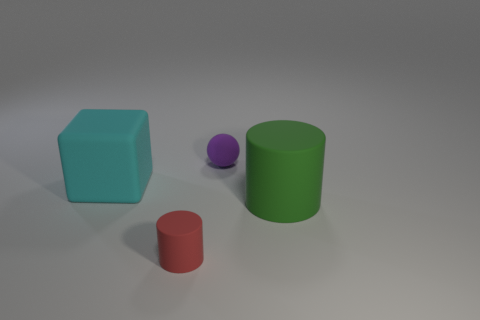Do the big green object and the small purple ball have the same material?
Make the answer very short. Yes. There is another object that is the same shape as the tiny red matte thing; what color is it?
Offer a terse response. Green. What number of large cubes are the same material as the purple ball?
Make the answer very short. 1. There is a red matte object; what number of green matte objects are in front of it?
Your answer should be very brief. 0. The red object has what size?
Provide a short and direct response. Small. The cylinder that is the same size as the ball is what color?
Give a very brief answer. Red. What is the material of the large cube?
Give a very brief answer. Rubber. How many big objects are there?
Provide a short and direct response. 2. How many other things are there of the same size as the cyan matte block?
Keep it short and to the point. 1. There is a tiny matte object that is behind the green thing; what is its color?
Offer a terse response. Purple. 